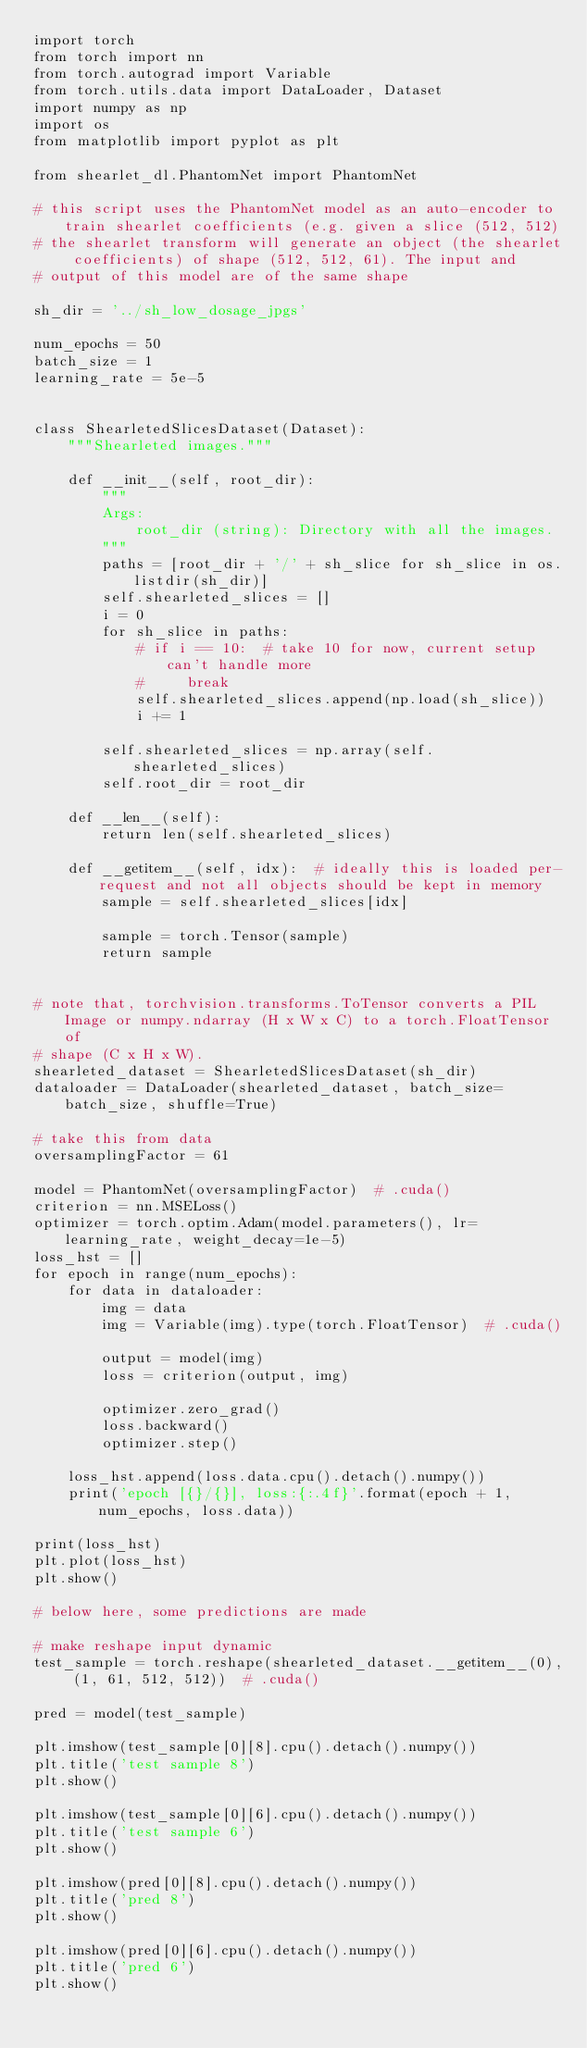Convert code to text. <code><loc_0><loc_0><loc_500><loc_500><_Python_>import torch
from torch import nn
from torch.autograd import Variable
from torch.utils.data import DataLoader, Dataset
import numpy as np
import os
from matplotlib import pyplot as plt

from shearlet_dl.PhantomNet import PhantomNet

# this script uses the PhantomNet model as an auto-encoder to train shearlet coefficients (e.g. given a slice (512, 512)
# the shearlet transform will generate an object (the shearlet coefficients) of shape (512, 512, 61). The input and
# output of this model are of the same shape

sh_dir = '../sh_low_dosage_jpgs'

num_epochs = 50
batch_size = 1
learning_rate = 5e-5


class ShearletedSlicesDataset(Dataset):
    """Shearleted images."""

    def __init__(self, root_dir):
        """
        Args:
            root_dir (string): Directory with all the images.
        """
        paths = [root_dir + '/' + sh_slice for sh_slice in os.listdir(sh_dir)]
        self.shearleted_slices = []
        i = 0
        for sh_slice in paths:
            # if i == 10:  # take 10 for now, current setup can't handle more
            #     break
            self.shearleted_slices.append(np.load(sh_slice))
            i += 1

        self.shearleted_slices = np.array(self.shearleted_slices)
        self.root_dir = root_dir

    def __len__(self):
        return len(self.shearleted_slices)

    def __getitem__(self, idx):  # ideally this is loaded per-request and not all objects should be kept in memory
        sample = self.shearleted_slices[idx]

        sample = torch.Tensor(sample)
        return sample


# note that, torchvision.transforms.ToTensor converts a PIL Image or numpy.ndarray (H x W x C) to a torch.FloatTensor of
# shape (C x H x W).
shearleted_dataset = ShearletedSlicesDataset(sh_dir)
dataloader = DataLoader(shearleted_dataset, batch_size=batch_size, shuffle=True)

# take this from data
oversamplingFactor = 61

model = PhantomNet(oversamplingFactor)  # .cuda()
criterion = nn.MSELoss()
optimizer = torch.optim.Adam(model.parameters(), lr=learning_rate, weight_decay=1e-5)
loss_hst = []
for epoch in range(num_epochs):
    for data in dataloader:
        img = data
        img = Variable(img).type(torch.FloatTensor)  # .cuda()

        output = model(img)
        loss = criterion(output, img)

        optimizer.zero_grad()
        loss.backward()
        optimizer.step()

    loss_hst.append(loss.data.cpu().detach().numpy())
    print('epoch [{}/{}], loss:{:.4f}'.format(epoch + 1, num_epochs, loss.data))

print(loss_hst)
plt.plot(loss_hst)
plt.show()

# below here, some predictions are made

# make reshape input dynamic
test_sample = torch.reshape(shearleted_dataset.__getitem__(0), (1, 61, 512, 512))  # .cuda()

pred = model(test_sample)

plt.imshow(test_sample[0][8].cpu().detach().numpy())
plt.title('test sample 8')
plt.show()

plt.imshow(test_sample[0][6].cpu().detach().numpy())
plt.title('test sample 6')
plt.show()

plt.imshow(pred[0][8].cpu().detach().numpy())
plt.title('pred 8')
plt.show()

plt.imshow(pred[0][6].cpu().detach().numpy())
plt.title('pred 6')
plt.show()
</code> 